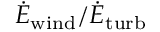<formula> <loc_0><loc_0><loc_500><loc_500>\dot { E } _ { w i n d } / \dot { E } _ { t u r b }</formula> 